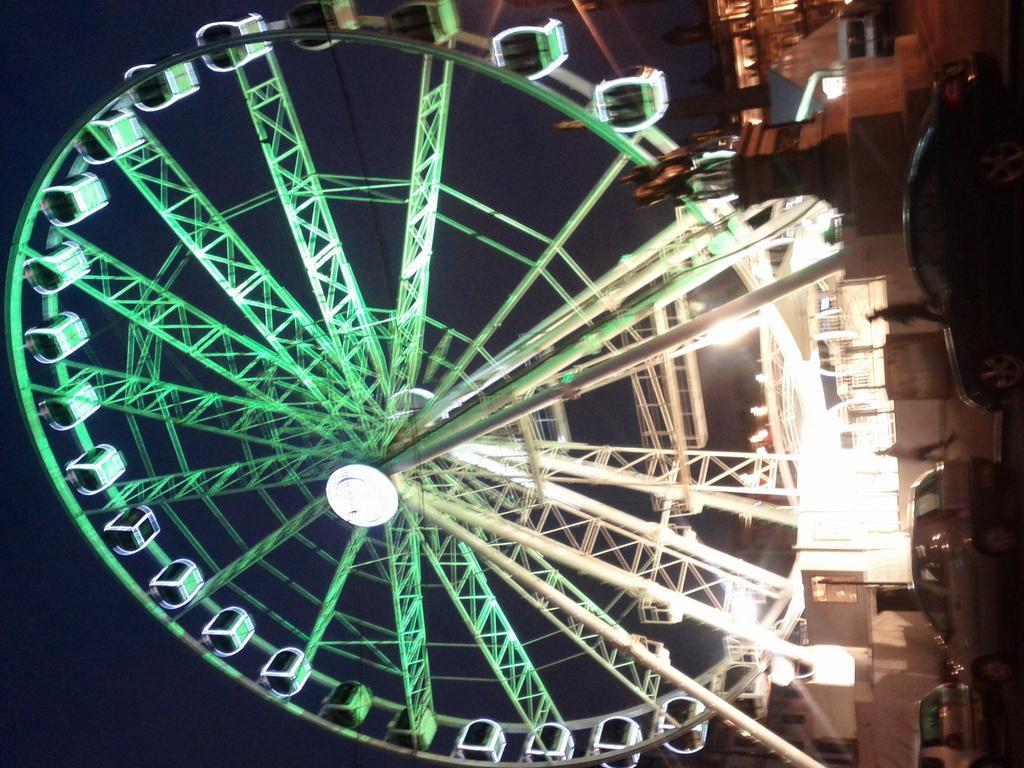Describe this image in one or two sentences. This image consists of a giant wheel. At the bottom, we can see vehicles which are parked on the road. And there is a statue. At the top, there is sky. And we can see many lights in this image. 